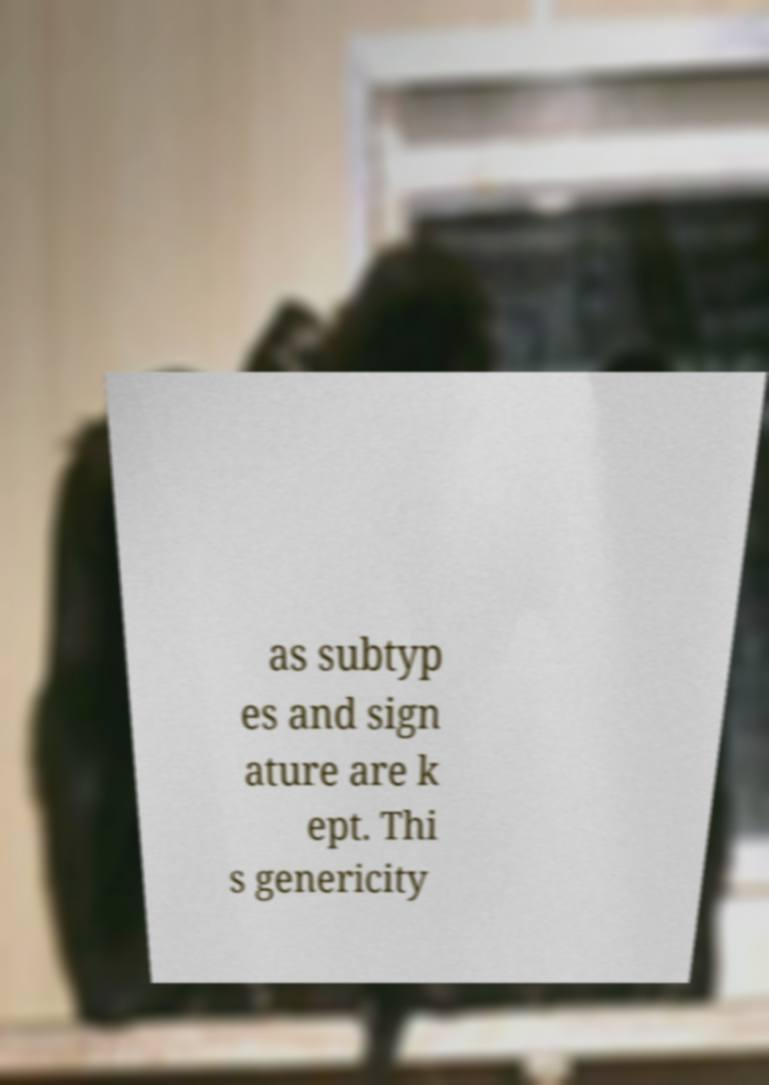Could you assist in decoding the text presented in this image and type it out clearly? as subtyp es and sign ature are k ept. Thi s genericity 